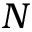Convert formula to latex. <formula><loc_0><loc_0><loc_500><loc_500>N</formula> 